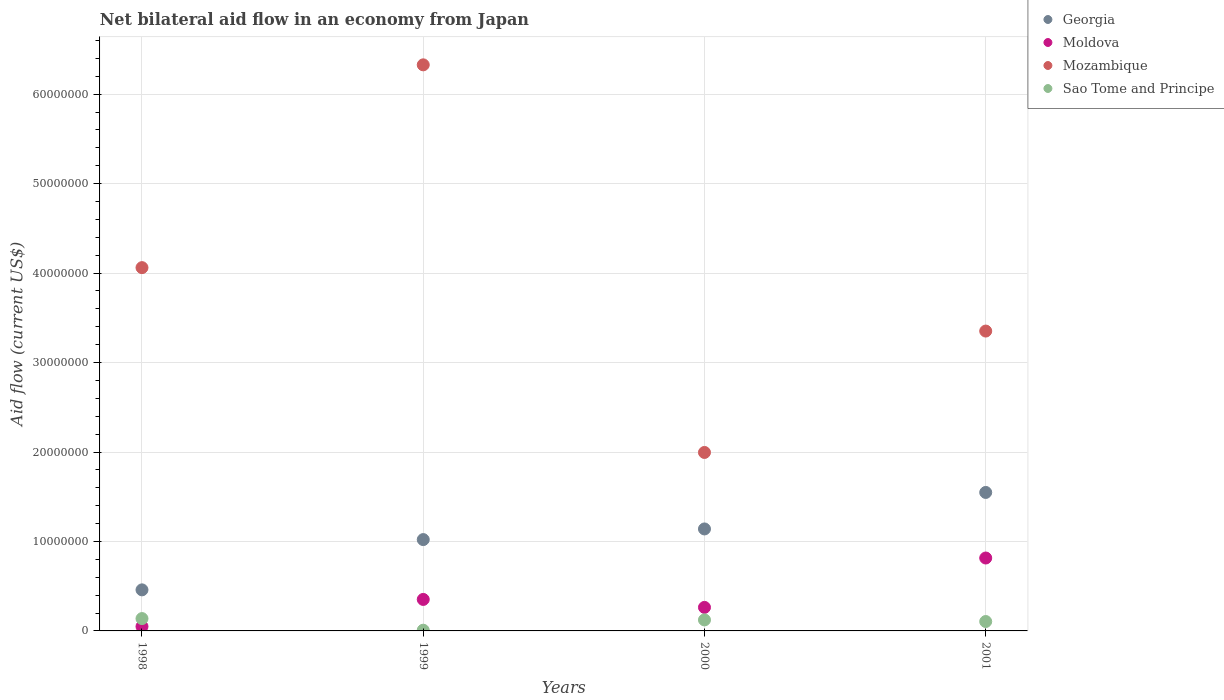Is the number of dotlines equal to the number of legend labels?
Make the answer very short. Yes. What is the net bilateral aid flow in Mozambique in 2001?
Give a very brief answer. 3.35e+07. Across all years, what is the maximum net bilateral aid flow in Sao Tome and Principe?
Your response must be concise. 1.38e+06. Across all years, what is the minimum net bilateral aid flow in Georgia?
Provide a succinct answer. 4.59e+06. In which year was the net bilateral aid flow in Moldova maximum?
Ensure brevity in your answer.  2001. In which year was the net bilateral aid flow in Mozambique minimum?
Provide a short and direct response. 2000. What is the total net bilateral aid flow in Georgia in the graph?
Keep it short and to the point. 4.17e+07. What is the difference between the net bilateral aid flow in Sao Tome and Principe in 1998 and that in 1999?
Offer a very short reply. 1.30e+06. What is the difference between the net bilateral aid flow in Moldova in 1998 and the net bilateral aid flow in Georgia in 2000?
Ensure brevity in your answer.  -1.09e+07. What is the average net bilateral aid flow in Georgia per year?
Offer a terse response. 1.04e+07. In the year 1999, what is the difference between the net bilateral aid flow in Georgia and net bilateral aid flow in Sao Tome and Principe?
Your answer should be very brief. 1.01e+07. What is the ratio of the net bilateral aid flow in Georgia in 1998 to that in 1999?
Make the answer very short. 0.45. Is the net bilateral aid flow in Mozambique in 2000 less than that in 2001?
Offer a terse response. Yes. Is the difference between the net bilateral aid flow in Georgia in 1999 and 2000 greater than the difference between the net bilateral aid flow in Sao Tome and Principe in 1999 and 2000?
Offer a very short reply. No. What is the difference between the highest and the second highest net bilateral aid flow in Mozambique?
Make the answer very short. 2.27e+07. What is the difference between the highest and the lowest net bilateral aid flow in Georgia?
Your answer should be very brief. 1.09e+07. Is the sum of the net bilateral aid flow in Mozambique in 1998 and 1999 greater than the maximum net bilateral aid flow in Sao Tome and Principe across all years?
Keep it short and to the point. Yes. Is it the case that in every year, the sum of the net bilateral aid flow in Mozambique and net bilateral aid flow in Sao Tome and Principe  is greater than the sum of net bilateral aid flow in Georgia and net bilateral aid flow in Moldova?
Give a very brief answer. Yes. Is it the case that in every year, the sum of the net bilateral aid flow in Sao Tome and Principe and net bilateral aid flow in Moldova  is greater than the net bilateral aid flow in Mozambique?
Keep it short and to the point. No. Does the net bilateral aid flow in Sao Tome and Principe monotonically increase over the years?
Provide a short and direct response. No. How many dotlines are there?
Ensure brevity in your answer.  4. Are the values on the major ticks of Y-axis written in scientific E-notation?
Make the answer very short. No. Does the graph contain any zero values?
Your response must be concise. No. Does the graph contain grids?
Provide a short and direct response. Yes. How many legend labels are there?
Ensure brevity in your answer.  4. What is the title of the graph?
Make the answer very short. Net bilateral aid flow in an economy from Japan. Does "Portugal" appear as one of the legend labels in the graph?
Your answer should be compact. No. What is the label or title of the X-axis?
Keep it short and to the point. Years. What is the label or title of the Y-axis?
Offer a terse response. Aid flow (current US$). What is the Aid flow (current US$) in Georgia in 1998?
Offer a very short reply. 4.59e+06. What is the Aid flow (current US$) of Mozambique in 1998?
Your answer should be very brief. 4.06e+07. What is the Aid flow (current US$) of Sao Tome and Principe in 1998?
Your answer should be compact. 1.38e+06. What is the Aid flow (current US$) of Georgia in 1999?
Provide a succinct answer. 1.02e+07. What is the Aid flow (current US$) of Moldova in 1999?
Your answer should be compact. 3.52e+06. What is the Aid flow (current US$) of Mozambique in 1999?
Offer a very short reply. 6.33e+07. What is the Aid flow (current US$) in Georgia in 2000?
Provide a succinct answer. 1.14e+07. What is the Aid flow (current US$) of Moldova in 2000?
Your response must be concise. 2.63e+06. What is the Aid flow (current US$) of Mozambique in 2000?
Keep it short and to the point. 2.00e+07. What is the Aid flow (current US$) in Sao Tome and Principe in 2000?
Make the answer very short. 1.23e+06. What is the Aid flow (current US$) in Georgia in 2001?
Ensure brevity in your answer.  1.55e+07. What is the Aid flow (current US$) in Moldova in 2001?
Offer a terse response. 8.15e+06. What is the Aid flow (current US$) in Mozambique in 2001?
Provide a succinct answer. 3.35e+07. What is the Aid flow (current US$) of Sao Tome and Principe in 2001?
Provide a short and direct response. 1.05e+06. Across all years, what is the maximum Aid flow (current US$) in Georgia?
Your response must be concise. 1.55e+07. Across all years, what is the maximum Aid flow (current US$) in Moldova?
Your answer should be compact. 8.15e+06. Across all years, what is the maximum Aid flow (current US$) in Mozambique?
Make the answer very short. 6.33e+07. Across all years, what is the maximum Aid flow (current US$) in Sao Tome and Principe?
Offer a terse response. 1.38e+06. Across all years, what is the minimum Aid flow (current US$) of Georgia?
Ensure brevity in your answer.  4.59e+06. Across all years, what is the minimum Aid flow (current US$) of Moldova?
Give a very brief answer. 4.90e+05. Across all years, what is the minimum Aid flow (current US$) in Mozambique?
Your response must be concise. 2.00e+07. Across all years, what is the minimum Aid flow (current US$) of Sao Tome and Principe?
Provide a succinct answer. 8.00e+04. What is the total Aid flow (current US$) of Georgia in the graph?
Your answer should be very brief. 4.17e+07. What is the total Aid flow (current US$) in Moldova in the graph?
Give a very brief answer. 1.48e+07. What is the total Aid flow (current US$) of Mozambique in the graph?
Your response must be concise. 1.57e+08. What is the total Aid flow (current US$) in Sao Tome and Principe in the graph?
Give a very brief answer. 3.74e+06. What is the difference between the Aid flow (current US$) of Georgia in 1998 and that in 1999?
Keep it short and to the point. -5.62e+06. What is the difference between the Aid flow (current US$) of Moldova in 1998 and that in 1999?
Provide a short and direct response. -3.03e+06. What is the difference between the Aid flow (current US$) in Mozambique in 1998 and that in 1999?
Ensure brevity in your answer.  -2.27e+07. What is the difference between the Aid flow (current US$) of Sao Tome and Principe in 1998 and that in 1999?
Your response must be concise. 1.30e+06. What is the difference between the Aid flow (current US$) in Georgia in 1998 and that in 2000?
Offer a terse response. -6.81e+06. What is the difference between the Aid flow (current US$) of Moldova in 1998 and that in 2000?
Offer a terse response. -2.14e+06. What is the difference between the Aid flow (current US$) of Mozambique in 1998 and that in 2000?
Your answer should be very brief. 2.07e+07. What is the difference between the Aid flow (current US$) of Georgia in 1998 and that in 2001?
Offer a terse response. -1.09e+07. What is the difference between the Aid flow (current US$) in Moldova in 1998 and that in 2001?
Offer a very short reply. -7.66e+06. What is the difference between the Aid flow (current US$) of Mozambique in 1998 and that in 2001?
Offer a terse response. 7.09e+06. What is the difference between the Aid flow (current US$) of Sao Tome and Principe in 1998 and that in 2001?
Make the answer very short. 3.30e+05. What is the difference between the Aid flow (current US$) in Georgia in 1999 and that in 2000?
Make the answer very short. -1.19e+06. What is the difference between the Aid flow (current US$) in Moldova in 1999 and that in 2000?
Keep it short and to the point. 8.90e+05. What is the difference between the Aid flow (current US$) in Mozambique in 1999 and that in 2000?
Ensure brevity in your answer.  4.33e+07. What is the difference between the Aid flow (current US$) in Sao Tome and Principe in 1999 and that in 2000?
Make the answer very short. -1.15e+06. What is the difference between the Aid flow (current US$) in Georgia in 1999 and that in 2001?
Keep it short and to the point. -5.27e+06. What is the difference between the Aid flow (current US$) of Moldova in 1999 and that in 2001?
Offer a terse response. -4.63e+06. What is the difference between the Aid flow (current US$) in Mozambique in 1999 and that in 2001?
Your answer should be very brief. 2.98e+07. What is the difference between the Aid flow (current US$) in Sao Tome and Principe in 1999 and that in 2001?
Offer a terse response. -9.70e+05. What is the difference between the Aid flow (current US$) of Georgia in 2000 and that in 2001?
Your response must be concise. -4.08e+06. What is the difference between the Aid flow (current US$) in Moldova in 2000 and that in 2001?
Offer a very short reply. -5.52e+06. What is the difference between the Aid flow (current US$) in Mozambique in 2000 and that in 2001?
Your answer should be very brief. -1.36e+07. What is the difference between the Aid flow (current US$) of Sao Tome and Principe in 2000 and that in 2001?
Your response must be concise. 1.80e+05. What is the difference between the Aid flow (current US$) of Georgia in 1998 and the Aid flow (current US$) of Moldova in 1999?
Ensure brevity in your answer.  1.07e+06. What is the difference between the Aid flow (current US$) of Georgia in 1998 and the Aid flow (current US$) of Mozambique in 1999?
Keep it short and to the point. -5.87e+07. What is the difference between the Aid flow (current US$) of Georgia in 1998 and the Aid flow (current US$) of Sao Tome and Principe in 1999?
Provide a succinct answer. 4.51e+06. What is the difference between the Aid flow (current US$) of Moldova in 1998 and the Aid flow (current US$) of Mozambique in 1999?
Your answer should be very brief. -6.28e+07. What is the difference between the Aid flow (current US$) of Moldova in 1998 and the Aid flow (current US$) of Sao Tome and Principe in 1999?
Keep it short and to the point. 4.10e+05. What is the difference between the Aid flow (current US$) of Mozambique in 1998 and the Aid flow (current US$) of Sao Tome and Principe in 1999?
Give a very brief answer. 4.05e+07. What is the difference between the Aid flow (current US$) of Georgia in 1998 and the Aid flow (current US$) of Moldova in 2000?
Provide a succinct answer. 1.96e+06. What is the difference between the Aid flow (current US$) in Georgia in 1998 and the Aid flow (current US$) in Mozambique in 2000?
Make the answer very short. -1.54e+07. What is the difference between the Aid flow (current US$) in Georgia in 1998 and the Aid flow (current US$) in Sao Tome and Principe in 2000?
Your answer should be compact. 3.36e+06. What is the difference between the Aid flow (current US$) in Moldova in 1998 and the Aid flow (current US$) in Mozambique in 2000?
Provide a short and direct response. -1.95e+07. What is the difference between the Aid flow (current US$) in Moldova in 1998 and the Aid flow (current US$) in Sao Tome and Principe in 2000?
Ensure brevity in your answer.  -7.40e+05. What is the difference between the Aid flow (current US$) of Mozambique in 1998 and the Aid flow (current US$) of Sao Tome and Principe in 2000?
Provide a short and direct response. 3.94e+07. What is the difference between the Aid flow (current US$) of Georgia in 1998 and the Aid flow (current US$) of Moldova in 2001?
Keep it short and to the point. -3.56e+06. What is the difference between the Aid flow (current US$) in Georgia in 1998 and the Aid flow (current US$) in Mozambique in 2001?
Give a very brief answer. -2.89e+07. What is the difference between the Aid flow (current US$) of Georgia in 1998 and the Aid flow (current US$) of Sao Tome and Principe in 2001?
Provide a succinct answer. 3.54e+06. What is the difference between the Aid flow (current US$) of Moldova in 1998 and the Aid flow (current US$) of Mozambique in 2001?
Keep it short and to the point. -3.30e+07. What is the difference between the Aid flow (current US$) in Moldova in 1998 and the Aid flow (current US$) in Sao Tome and Principe in 2001?
Your answer should be very brief. -5.60e+05. What is the difference between the Aid flow (current US$) of Mozambique in 1998 and the Aid flow (current US$) of Sao Tome and Principe in 2001?
Provide a short and direct response. 3.96e+07. What is the difference between the Aid flow (current US$) of Georgia in 1999 and the Aid flow (current US$) of Moldova in 2000?
Make the answer very short. 7.58e+06. What is the difference between the Aid flow (current US$) in Georgia in 1999 and the Aid flow (current US$) in Mozambique in 2000?
Provide a short and direct response. -9.74e+06. What is the difference between the Aid flow (current US$) of Georgia in 1999 and the Aid flow (current US$) of Sao Tome and Principe in 2000?
Offer a terse response. 8.98e+06. What is the difference between the Aid flow (current US$) in Moldova in 1999 and the Aid flow (current US$) in Mozambique in 2000?
Offer a terse response. -1.64e+07. What is the difference between the Aid flow (current US$) of Moldova in 1999 and the Aid flow (current US$) of Sao Tome and Principe in 2000?
Your response must be concise. 2.29e+06. What is the difference between the Aid flow (current US$) in Mozambique in 1999 and the Aid flow (current US$) in Sao Tome and Principe in 2000?
Offer a very short reply. 6.20e+07. What is the difference between the Aid flow (current US$) of Georgia in 1999 and the Aid flow (current US$) of Moldova in 2001?
Your answer should be compact. 2.06e+06. What is the difference between the Aid flow (current US$) in Georgia in 1999 and the Aid flow (current US$) in Mozambique in 2001?
Your answer should be compact. -2.33e+07. What is the difference between the Aid flow (current US$) of Georgia in 1999 and the Aid flow (current US$) of Sao Tome and Principe in 2001?
Offer a terse response. 9.16e+06. What is the difference between the Aid flow (current US$) of Moldova in 1999 and the Aid flow (current US$) of Mozambique in 2001?
Provide a short and direct response. -3.00e+07. What is the difference between the Aid flow (current US$) in Moldova in 1999 and the Aid flow (current US$) in Sao Tome and Principe in 2001?
Offer a terse response. 2.47e+06. What is the difference between the Aid flow (current US$) in Mozambique in 1999 and the Aid flow (current US$) in Sao Tome and Principe in 2001?
Offer a terse response. 6.22e+07. What is the difference between the Aid flow (current US$) in Georgia in 2000 and the Aid flow (current US$) in Moldova in 2001?
Offer a very short reply. 3.25e+06. What is the difference between the Aid flow (current US$) of Georgia in 2000 and the Aid flow (current US$) of Mozambique in 2001?
Your response must be concise. -2.21e+07. What is the difference between the Aid flow (current US$) of Georgia in 2000 and the Aid flow (current US$) of Sao Tome and Principe in 2001?
Your answer should be very brief. 1.04e+07. What is the difference between the Aid flow (current US$) of Moldova in 2000 and the Aid flow (current US$) of Mozambique in 2001?
Provide a succinct answer. -3.09e+07. What is the difference between the Aid flow (current US$) of Moldova in 2000 and the Aid flow (current US$) of Sao Tome and Principe in 2001?
Provide a short and direct response. 1.58e+06. What is the difference between the Aid flow (current US$) of Mozambique in 2000 and the Aid flow (current US$) of Sao Tome and Principe in 2001?
Your answer should be very brief. 1.89e+07. What is the average Aid flow (current US$) in Georgia per year?
Provide a short and direct response. 1.04e+07. What is the average Aid flow (current US$) of Moldova per year?
Keep it short and to the point. 3.70e+06. What is the average Aid flow (current US$) of Mozambique per year?
Give a very brief answer. 3.93e+07. What is the average Aid flow (current US$) in Sao Tome and Principe per year?
Offer a very short reply. 9.35e+05. In the year 1998, what is the difference between the Aid flow (current US$) in Georgia and Aid flow (current US$) in Moldova?
Offer a very short reply. 4.10e+06. In the year 1998, what is the difference between the Aid flow (current US$) in Georgia and Aid flow (current US$) in Mozambique?
Your answer should be compact. -3.60e+07. In the year 1998, what is the difference between the Aid flow (current US$) of Georgia and Aid flow (current US$) of Sao Tome and Principe?
Give a very brief answer. 3.21e+06. In the year 1998, what is the difference between the Aid flow (current US$) in Moldova and Aid flow (current US$) in Mozambique?
Offer a terse response. -4.01e+07. In the year 1998, what is the difference between the Aid flow (current US$) in Moldova and Aid flow (current US$) in Sao Tome and Principe?
Offer a very short reply. -8.90e+05. In the year 1998, what is the difference between the Aid flow (current US$) of Mozambique and Aid flow (current US$) of Sao Tome and Principe?
Your answer should be compact. 3.92e+07. In the year 1999, what is the difference between the Aid flow (current US$) of Georgia and Aid flow (current US$) of Moldova?
Your response must be concise. 6.69e+06. In the year 1999, what is the difference between the Aid flow (current US$) in Georgia and Aid flow (current US$) in Mozambique?
Provide a succinct answer. -5.31e+07. In the year 1999, what is the difference between the Aid flow (current US$) of Georgia and Aid flow (current US$) of Sao Tome and Principe?
Your answer should be very brief. 1.01e+07. In the year 1999, what is the difference between the Aid flow (current US$) in Moldova and Aid flow (current US$) in Mozambique?
Provide a succinct answer. -5.98e+07. In the year 1999, what is the difference between the Aid flow (current US$) of Moldova and Aid flow (current US$) of Sao Tome and Principe?
Ensure brevity in your answer.  3.44e+06. In the year 1999, what is the difference between the Aid flow (current US$) in Mozambique and Aid flow (current US$) in Sao Tome and Principe?
Provide a short and direct response. 6.32e+07. In the year 2000, what is the difference between the Aid flow (current US$) in Georgia and Aid flow (current US$) in Moldova?
Offer a very short reply. 8.77e+06. In the year 2000, what is the difference between the Aid flow (current US$) of Georgia and Aid flow (current US$) of Mozambique?
Your answer should be compact. -8.55e+06. In the year 2000, what is the difference between the Aid flow (current US$) of Georgia and Aid flow (current US$) of Sao Tome and Principe?
Your answer should be compact. 1.02e+07. In the year 2000, what is the difference between the Aid flow (current US$) of Moldova and Aid flow (current US$) of Mozambique?
Provide a succinct answer. -1.73e+07. In the year 2000, what is the difference between the Aid flow (current US$) in Moldova and Aid flow (current US$) in Sao Tome and Principe?
Offer a terse response. 1.40e+06. In the year 2000, what is the difference between the Aid flow (current US$) in Mozambique and Aid flow (current US$) in Sao Tome and Principe?
Provide a succinct answer. 1.87e+07. In the year 2001, what is the difference between the Aid flow (current US$) in Georgia and Aid flow (current US$) in Moldova?
Provide a short and direct response. 7.33e+06. In the year 2001, what is the difference between the Aid flow (current US$) in Georgia and Aid flow (current US$) in Mozambique?
Provide a short and direct response. -1.80e+07. In the year 2001, what is the difference between the Aid flow (current US$) of Georgia and Aid flow (current US$) of Sao Tome and Principe?
Provide a succinct answer. 1.44e+07. In the year 2001, what is the difference between the Aid flow (current US$) of Moldova and Aid flow (current US$) of Mozambique?
Give a very brief answer. -2.54e+07. In the year 2001, what is the difference between the Aid flow (current US$) of Moldova and Aid flow (current US$) of Sao Tome and Principe?
Your response must be concise. 7.10e+06. In the year 2001, what is the difference between the Aid flow (current US$) of Mozambique and Aid flow (current US$) of Sao Tome and Principe?
Your answer should be compact. 3.25e+07. What is the ratio of the Aid flow (current US$) in Georgia in 1998 to that in 1999?
Provide a short and direct response. 0.45. What is the ratio of the Aid flow (current US$) in Moldova in 1998 to that in 1999?
Provide a short and direct response. 0.14. What is the ratio of the Aid flow (current US$) of Mozambique in 1998 to that in 1999?
Ensure brevity in your answer.  0.64. What is the ratio of the Aid flow (current US$) in Sao Tome and Principe in 1998 to that in 1999?
Offer a terse response. 17.25. What is the ratio of the Aid flow (current US$) of Georgia in 1998 to that in 2000?
Keep it short and to the point. 0.4. What is the ratio of the Aid flow (current US$) in Moldova in 1998 to that in 2000?
Make the answer very short. 0.19. What is the ratio of the Aid flow (current US$) of Mozambique in 1998 to that in 2000?
Make the answer very short. 2.04. What is the ratio of the Aid flow (current US$) of Sao Tome and Principe in 1998 to that in 2000?
Offer a terse response. 1.12. What is the ratio of the Aid flow (current US$) in Georgia in 1998 to that in 2001?
Provide a succinct answer. 0.3. What is the ratio of the Aid flow (current US$) of Moldova in 1998 to that in 2001?
Your answer should be very brief. 0.06. What is the ratio of the Aid flow (current US$) in Mozambique in 1998 to that in 2001?
Your response must be concise. 1.21. What is the ratio of the Aid flow (current US$) of Sao Tome and Principe in 1998 to that in 2001?
Keep it short and to the point. 1.31. What is the ratio of the Aid flow (current US$) in Georgia in 1999 to that in 2000?
Make the answer very short. 0.9. What is the ratio of the Aid flow (current US$) of Moldova in 1999 to that in 2000?
Offer a terse response. 1.34. What is the ratio of the Aid flow (current US$) of Mozambique in 1999 to that in 2000?
Your answer should be very brief. 3.17. What is the ratio of the Aid flow (current US$) in Sao Tome and Principe in 1999 to that in 2000?
Your answer should be compact. 0.07. What is the ratio of the Aid flow (current US$) of Georgia in 1999 to that in 2001?
Give a very brief answer. 0.66. What is the ratio of the Aid flow (current US$) of Moldova in 1999 to that in 2001?
Ensure brevity in your answer.  0.43. What is the ratio of the Aid flow (current US$) in Mozambique in 1999 to that in 2001?
Ensure brevity in your answer.  1.89. What is the ratio of the Aid flow (current US$) in Sao Tome and Principe in 1999 to that in 2001?
Your answer should be compact. 0.08. What is the ratio of the Aid flow (current US$) in Georgia in 2000 to that in 2001?
Your answer should be compact. 0.74. What is the ratio of the Aid flow (current US$) of Moldova in 2000 to that in 2001?
Your response must be concise. 0.32. What is the ratio of the Aid flow (current US$) in Mozambique in 2000 to that in 2001?
Make the answer very short. 0.6. What is the ratio of the Aid flow (current US$) of Sao Tome and Principe in 2000 to that in 2001?
Keep it short and to the point. 1.17. What is the difference between the highest and the second highest Aid flow (current US$) in Georgia?
Make the answer very short. 4.08e+06. What is the difference between the highest and the second highest Aid flow (current US$) of Moldova?
Give a very brief answer. 4.63e+06. What is the difference between the highest and the second highest Aid flow (current US$) of Mozambique?
Your answer should be compact. 2.27e+07. What is the difference between the highest and the lowest Aid flow (current US$) of Georgia?
Offer a terse response. 1.09e+07. What is the difference between the highest and the lowest Aid flow (current US$) in Moldova?
Offer a very short reply. 7.66e+06. What is the difference between the highest and the lowest Aid flow (current US$) in Mozambique?
Your response must be concise. 4.33e+07. What is the difference between the highest and the lowest Aid flow (current US$) in Sao Tome and Principe?
Your response must be concise. 1.30e+06. 